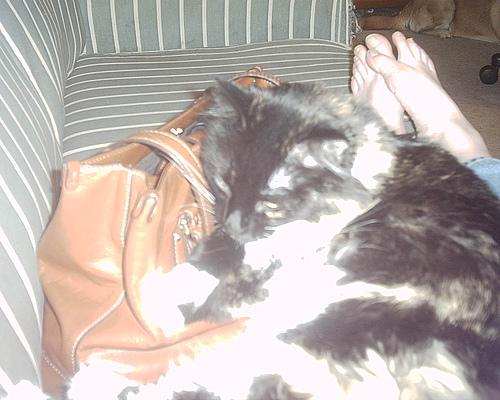Where does the cat rest? Please explain your reasoning. couch. The cat is on the couch. 